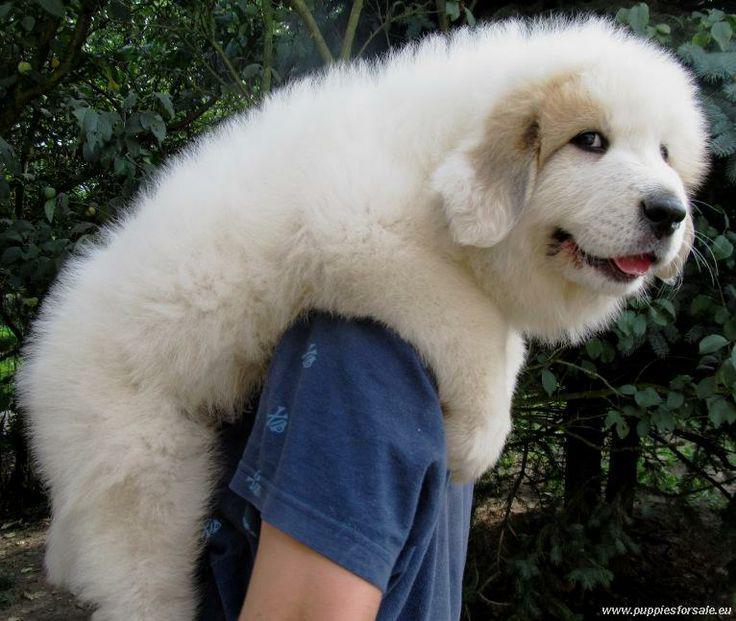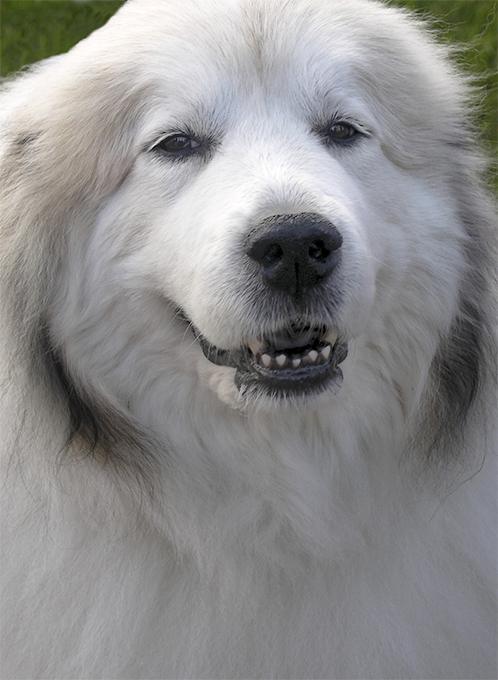The first image is the image on the left, the second image is the image on the right. For the images displayed, is the sentence "Left image shows fluffy dog standing on green grass." factually correct? Answer yes or no. No. The first image is the image on the left, the second image is the image on the right. Assess this claim about the two images: "One of the dogs is standing in a side profile pose.". Correct or not? Answer yes or no. No. 